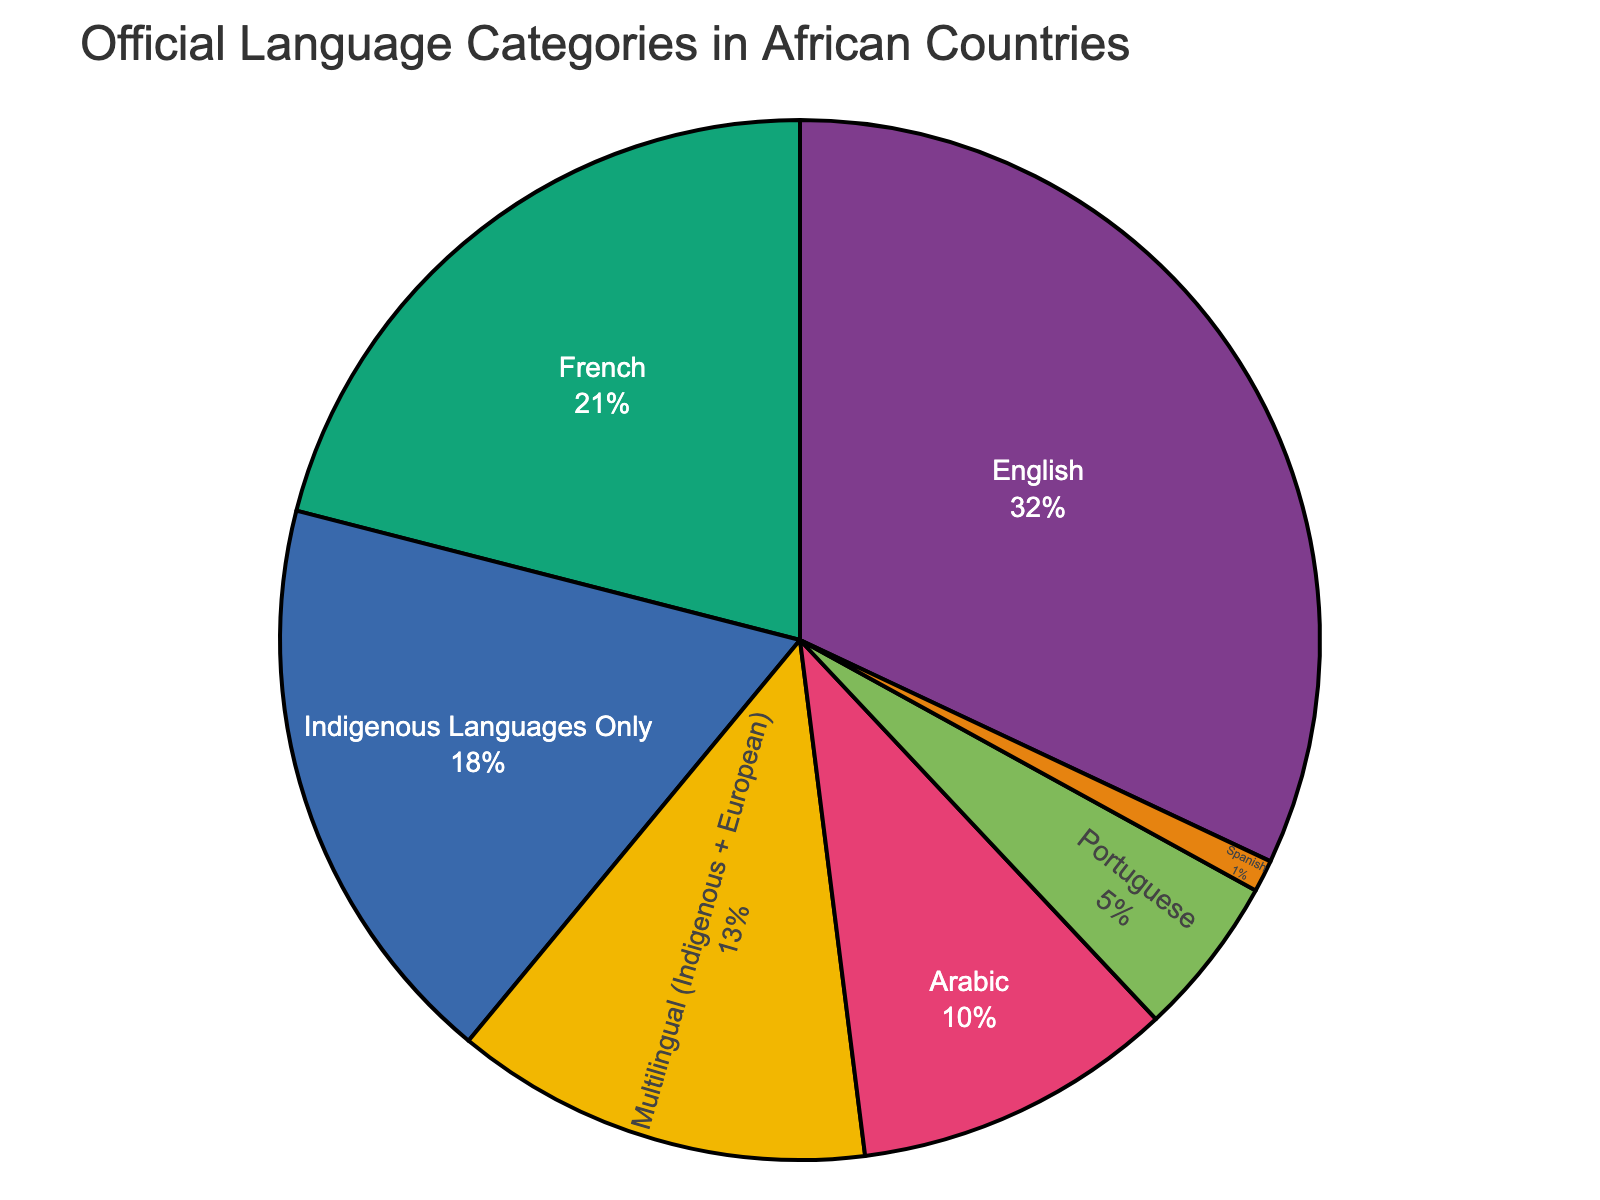What is the category with the highest percentage? The figure shows different language categories by their percentage. The category with the highest percentage is English.
Answer: English How does the percentage of French-speaking countries compare to English-speaking countries? By looking at the figure, the percentage of French-speaking countries is 21%, while English-speaking countries are 32%. Thus, English-speaking countries have a higher percentage than French-speaking countries.
Answer: English-speaking countries have a higher percentage What is the combined percentage of countries with Arabic and Portuguese as official languages? The percentage for Arabic is 10%, and for Portuguese, it is 5%. Adding these together gives 10% + 5% = 15%.
Answer: 15% Which language category or categories have a percentage below 10%? The figure shows percentages for each category. The only category with a percentage below 10% is Spanish, which is at 1%.
Answer: Spanish What is the difference in percentage between countries that have Indigenous Languages Only and those that are Multilingual (Indigenous + European)? The percentage for Indigenous Languages Only is 18%, and for Multilingual, it is 13%. The difference is 18% - 13% = 5%.
Answer: 5% What are the percentages for multilingual and Spanish-speaking countries combined? The percentage for Multilingual is 13%, and for Spanish, it is 1%. Adding these gives 13% + 1% = 14%.
Answer: 14% Is the number of countries with Indigenous Languages Only greater than the number of Arabic-speaking countries? By looking at the percentages, 18% of countries have Indigenous Languages Only, while 10% have Arabic as an official language. Since 18% is greater than 10%, there are more countries with Indigenous Languages Only.
Answer: Yes Which category appears to occupy the smallest portion of the pie chart? Observing the visual distribution, Spanish-speaking countries occupy the smallest portion of the pie chart.
Answer: Spanish Is the combined percentage of countries speaking Portuguese and Spanish higher than those speaking Arabic? The percentage for Portuguese is 5% and for Spanish is 1%, making a total of 5% + 1% = 6%. The percentage for Arabic is 10%. Therefore, 6% is less than 10%.
Answer: No By how much does the percentage of countries where French is an official language exceed that where Portuguese is an official language? The percentage for French is 21%, and for Portuguese, it is 5%. The difference is 21% - 5% = 16%.
Answer: 16% 